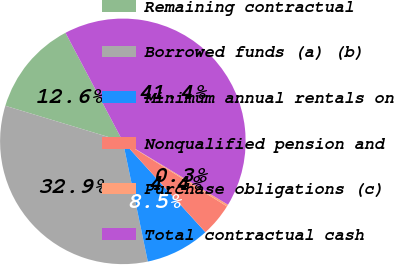Convert chart. <chart><loc_0><loc_0><loc_500><loc_500><pie_chart><fcel>Remaining contractual<fcel>Borrowed funds (a) (b)<fcel>Minimum annual rentals on<fcel>Nonqualified pension and<fcel>Purchase obligations (c)<fcel>Total contractual cash<nl><fcel>12.59%<fcel>32.94%<fcel>8.48%<fcel>4.37%<fcel>0.26%<fcel>41.37%<nl></chart> 